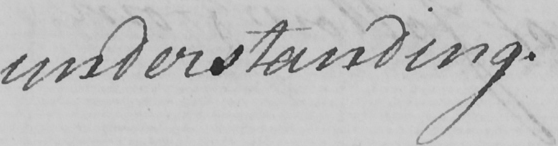What text is written in this handwritten line? understanding . 